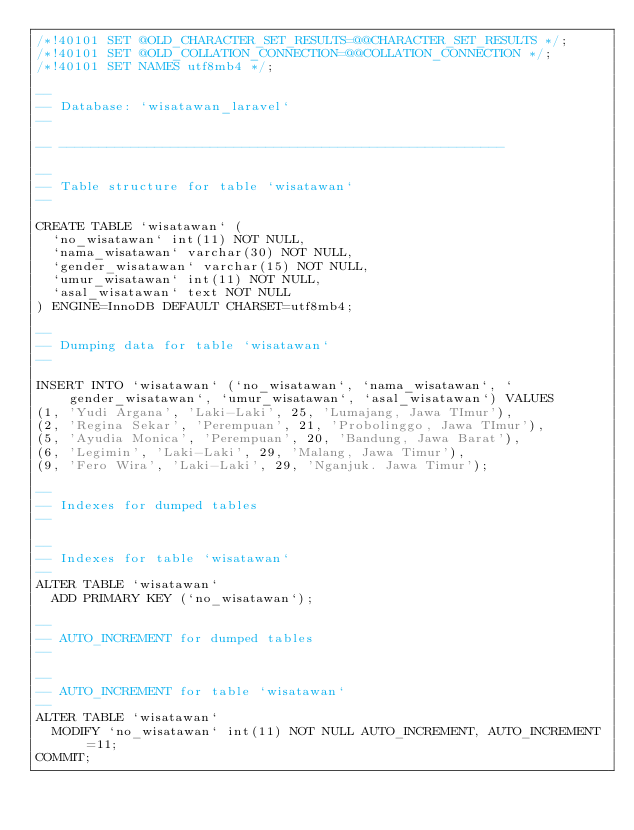<code> <loc_0><loc_0><loc_500><loc_500><_SQL_>/*!40101 SET @OLD_CHARACTER_SET_RESULTS=@@CHARACTER_SET_RESULTS */;
/*!40101 SET @OLD_COLLATION_CONNECTION=@@COLLATION_CONNECTION */;
/*!40101 SET NAMES utf8mb4 */;

--
-- Database: `wisatawan_laravel`
--

-- --------------------------------------------------------

--
-- Table structure for table `wisatawan`
--

CREATE TABLE `wisatawan` (
  `no_wisatawan` int(11) NOT NULL,
  `nama_wisatawan` varchar(30) NOT NULL,
  `gender_wisatawan` varchar(15) NOT NULL,
  `umur_wisatawan` int(11) NOT NULL,
  `asal_wisatawan` text NOT NULL
) ENGINE=InnoDB DEFAULT CHARSET=utf8mb4;

--
-- Dumping data for table `wisatawan`
--

INSERT INTO `wisatawan` (`no_wisatawan`, `nama_wisatawan`, `gender_wisatawan`, `umur_wisatawan`, `asal_wisatawan`) VALUES
(1, 'Yudi Argana', 'Laki-Laki', 25, 'Lumajang, Jawa TImur'),
(2, 'Regina Sekar', 'Perempuan', 21, 'Probolinggo, Jawa TImur'),
(5, 'Ayudia Monica', 'Perempuan', 20, 'Bandung, Jawa Barat'),
(6, 'Legimin', 'Laki-Laki', 29, 'Malang, Jawa Timur'),
(9, 'Fero Wira', 'Laki-Laki', 29, 'Nganjuk. Jawa Timur');

--
-- Indexes for dumped tables
--

--
-- Indexes for table `wisatawan`
--
ALTER TABLE `wisatawan`
  ADD PRIMARY KEY (`no_wisatawan`);

--
-- AUTO_INCREMENT for dumped tables
--

--
-- AUTO_INCREMENT for table `wisatawan`
--
ALTER TABLE `wisatawan`
  MODIFY `no_wisatawan` int(11) NOT NULL AUTO_INCREMENT, AUTO_INCREMENT=11;
COMMIT;
</code> 